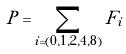<formula> <loc_0><loc_0><loc_500><loc_500>P = \sum _ { i = ( 0 , 1 , 2 , 4 , 8 ) } F _ { i }</formula> 